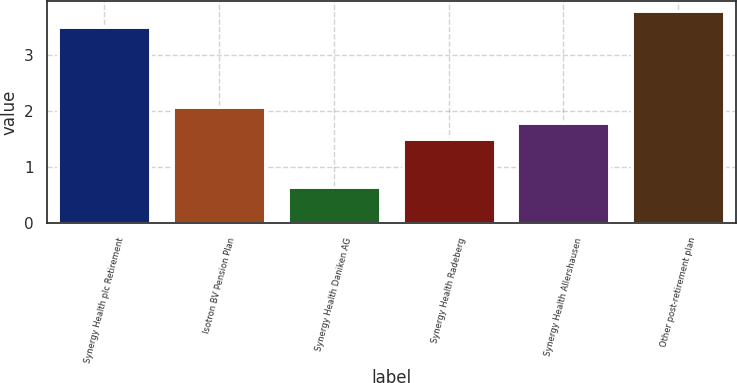Convert chart to OTSL. <chart><loc_0><loc_0><loc_500><loc_500><bar_chart><fcel>Synergy Health plc Retirement<fcel>Isotron BV Pension Plan<fcel>Synergy Health Daniken AG<fcel>Synergy Health Radeberg<fcel>Synergy Health Allershausen<fcel>Other post-retirement plan<nl><fcel>3.5<fcel>2.08<fcel>0.65<fcel>1.5<fcel>1.79<fcel>3.79<nl></chart> 